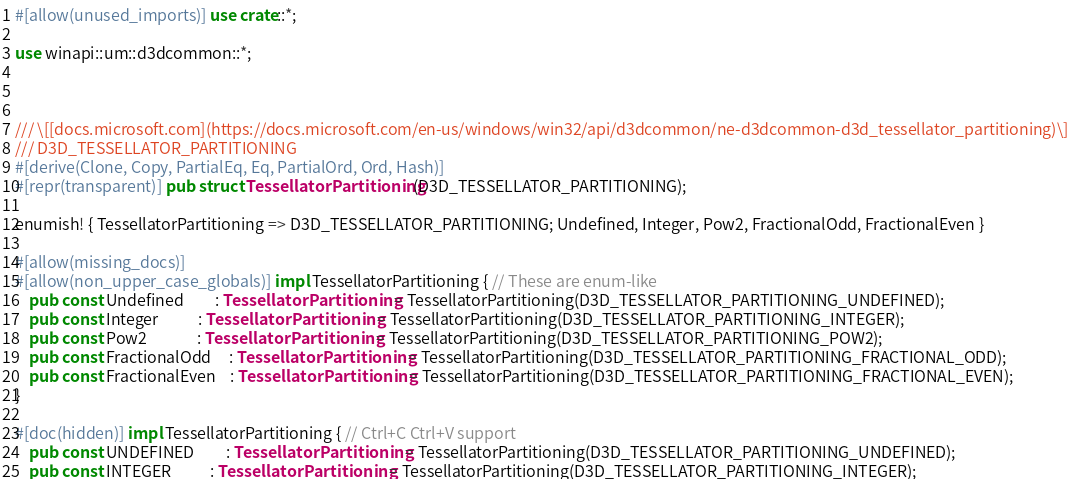<code> <loc_0><loc_0><loc_500><loc_500><_Rust_>#[allow(unused_imports)] use crate::*;

use winapi::um::d3dcommon::*;



/// \[[docs.microsoft.com](https://docs.microsoft.com/en-us/windows/win32/api/d3dcommon/ne-d3dcommon-d3d_tessellator_partitioning)\]
/// D3D_TESSELLATOR_PARTITIONING
#[derive(Clone, Copy, PartialEq, Eq, PartialOrd, Ord, Hash)]
#[repr(transparent)] pub struct TessellatorPartitioning(D3D_TESSELLATOR_PARTITIONING);

enumish! { TessellatorPartitioning => D3D_TESSELLATOR_PARTITIONING; Undefined, Integer, Pow2, FractionalOdd, FractionalEven }

#[allow(missing_docs)]
#[allow(non_upper_case_globals)] impl TessellatorPartitioning { // These are enum-like
    pub const Undefined         : TessellatorPartitioning = TessellatorPartitioning(D3D_TESSELLATOR_PARTITIONING_UNDEFINED);
    pub const Integer           : TessellatorPartitioning = TessellatorPartitioning(D3D_TESSELLATOR_PARTITIONING_INTEGER);
    pub const Pow2              : TessellatorPartitioning = TessellatorPartitioning(D3D_TESSELLATOR_PARTITIONING_POW2);
    pub const FractionalOdd     : TessellatorPartitioning = TessellatorPartitioning(D3D_TESSELLATOR_PARTITIONING_FRACTIONAL_ODD);
    pub const FractionalEven    : TessellatorPartitioning = TessellatorPartitioning(D3D_TESSELLATOR_PARTITIONING_FRACTIONAL_EVEN);
}

#[doc(hidden)] impl TessellatorPartitioning { // Ctrl+C Ctrl+V support
    pub const UNDEFINED         : TessellatorPartitioning = TessellatorPartitioning(D3D_TESSELLATOR_PARTITIONING_UNDEFINED);
    pub const INTEGER           : TessellatorPartitioning = TessellatorPartitioning(D3D_TESSELLATOR_PARTITIONING_INTEGER);</code> 